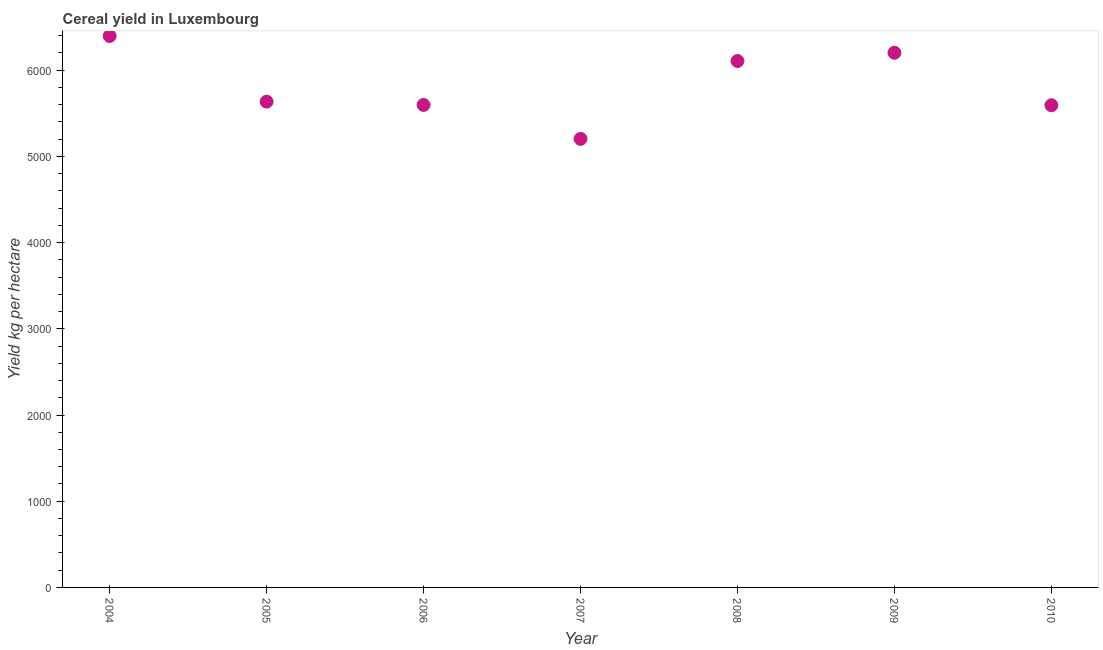What is the cereal yield in 2005?
Your answer should be compact. 5634.79. Across all years, what is the maximum cereal yield?
Ensure brevity in your answer.  6396.63. Across all years, what is the minimum cereal yield?
Offer a terse response. 5202.93. What is the sum of the cereal yield?
Offer a terse response. 4.07e+04. What is the difference between the cereal yield in 2008 and 2010?
Ensure brevity in your answer.  513.08. What is the average cereal yield per year?
Make the answer very short. 5818.99. What is the median cereal yield?
Offer a terse response. 5634.79. In how many years, is the cereal yield greater than 2200 kg per hectare?
Offer a terse response. 7. Do a majority of the years between 2007 and 2006 (inclusive) have cereal yield greater than 2600 kg per hectare?
Give a very brief answer. No. What is the ratio of the cereal yield in 2006 to that in 2007?
Make the answer very short. 1.08. Is the cereal yield in 2008 less than that in 2009?
Give a very brief answer. Yes. Is the difference between the cereal yield in 2008 and 2010 greater than the difference between any two years?
Ensure brevity in your answer.  No. What is the difference between the highest and the second highest cereal yield?
Give a very brief answer. 194.54. What is the difference between the highest and the lowest cereal yield?
Your answer should be very brief. 1193.7. In how many years, is the cereal yield greater than the average cereal yield taken over all years?
Your response must be concise. 3. Does the cereal yield monotonically increase over the years?
Offer a terse response. No. Does the graph contain any zero values?
Provide a short and direct response. No. Does the graph contain grids?
Give a very brief answer. No. What is the title of the graph?
Make the answer very short. Cereal yield in Luxembourg. What is the label or title of the Y-axis?
Provide a succinct answer. Yield kg per hectare. What is the Yield kg per hectare in 2004?
Keep it short and to the point. 6396.63. What is the Yield kg per hectare in 2005?
Ensure brevity in your answer.  5634.79. What is the Yield kg per hectare in 2006?
Provide a succinct answer. 5596.76. What is the Yield kg per hectare in 2007?
Provide a short and direct response. 5202.93. What is the Yield kg per hectare in 2008?
Ensure brevity in your answer.  6106.43. What is the Yield kg per hectare in 2009?
Provide a short and direct response. 6202.09. What is the Yield kg per hectare in 2010?
Your answer should be compact. 5593.35. What is the difference between the Yield kg per hectare in 2004 and 2005?
Your response must be concise. 761.84. What is the difference between the Yield kg per hectare in 2004 and 2006?
Provide a succinct answer. 799.86. What is the difference between the Yield kg per hectare in 2004 and 2007?
Your answer should be compact. 1193.7. What is the difference between the Yield kg per hectare in 2004 and 2008?
Your answer should be very brief. 290.2. What is the difference between the Yield kg per hectare in 2004 and 2009?
Make the answer very short. 194.54. What is the difference between the Yield kg per hectare in 2004 and 2010?
Provide a succinct answer. 803.28. What is the difference between the Yield kg per hectare in 2005 and 2006?
Your answer should be compact. 38.03. What is the difference between the Yield kg per hectare in 2005 and 2007?
Offer a terse response. 431.87. What is the difference between the Yield kg per hectare in 2005 and 2008?
Give a very brief answer. -471.63. What is the difference between the Yield kg per hectare in 2005 and 2009?
Your response must be concise. -567.29. What is the difference between the Yield kg per hectare in 2005 and 2010?
Your response must be concise. 41.44. What is the difference between the Yield kg per hectare in 2006 and 2007?
Your answer should be compact. 393.84. What is the difference between the Yield kg per hectare in 2006 and 2008?
Keep it short and to the point. -509.66. What is the difference between the Yield kg per hectare in 2006 and 2009?
Offer a very short reply. -605.32. What is the difference between the Yield kg per hectare in 2006 and 2010?
Your answer should be compact. 3.41. What is the difference between the Yield kg per hectare in 2007 and 2008?
Ensure brevity in your answer.  -903.5. What is the difference between the Yield kg per hectare in 2007 and 2009?
Your response must be concise. -999.16. What is the difference between the Yield kg per hectare in 2007 and 2010?
Make the answer very short. -390.42. What is the difference between the Yield kg per hectare in 2008 and 2009?
Keep it short and to the point. -95.66. What is the difference between the Yield kg per hectare in 2008 and 2010?
Keep it short and to the point. 513.08. What is the difference between the Yield kg per hectare in 2009 and 2010?
Ensure brevity in your answer.  608.74. What is the ratio of the Yield kg per hectare in 2004 to that in 2005?
Offer a very short reply. 1.14. What is the ratio of the Yield kg per hectare in 2004 to that in 2006?
Your answer should be compact. 1.14. What is the ratio of the Yield kg per hectare in 2004 to that in 2007?
Offer a terse response. 1.23. What is the ratio of the Yield kg per hectare in 2004 to that in 2008?
Your response must be concise. 1.05. What is the ratio of the Yield kg per hectare in 2004 to that in 2009?
Your response must be concise. 1.03. What is the ratio of the Yield kg per hectare in 2004 to that in 2010?
Make the answer very short. 1.14. What is the ratio of the Yield kg per hectare in 2005 to that in 2006?
Give a very brief answer. 1.01. What is the ratio of the Yield kg per hectare in 2005 to that in 2007?
Your response must be concise. 1.08. What is the ratio of the Yield kg per hectare in 2005 to that in 2008?
Provide a short and direct response. 0.92. What is the ratio of the Yield kg per hectare in 2005 to that in 2009?
Ensure brevity in your answer.  0.91. What is the ratio of the Yield kg per hectare in 2006 to that in 2007?
Ensure brevity in your answer.  1.08. What is the ratio of the Yield kg per hectare in 2006 to that in 2008?
Ensure brevity in your answer.  0.92. What is the ratio of the Yield kg per hectare in 2006 to that in 2009?
Provide a short and direct response. 0.9. What is the ratio of the Yield kg per hectare in 2007 to that in 2008?
Your response must be concise. 0.85. What is the ratio of the Yield kg per hectare in 2007 to that in 2009?
Your response must be concise. 0.84. What is the ratio of the Yield kg per hectare in 2008 to that in 2009?
Your answer should be very brief. 0.98. What is the ratio of the Yield kg per hectare in 2008 to that in 2010?
Offer a very short reply. 1.09. What is the ratio of the Yield kg per hectare in 2009 to that in 2010?
Offer a very short reply. 1.11. 